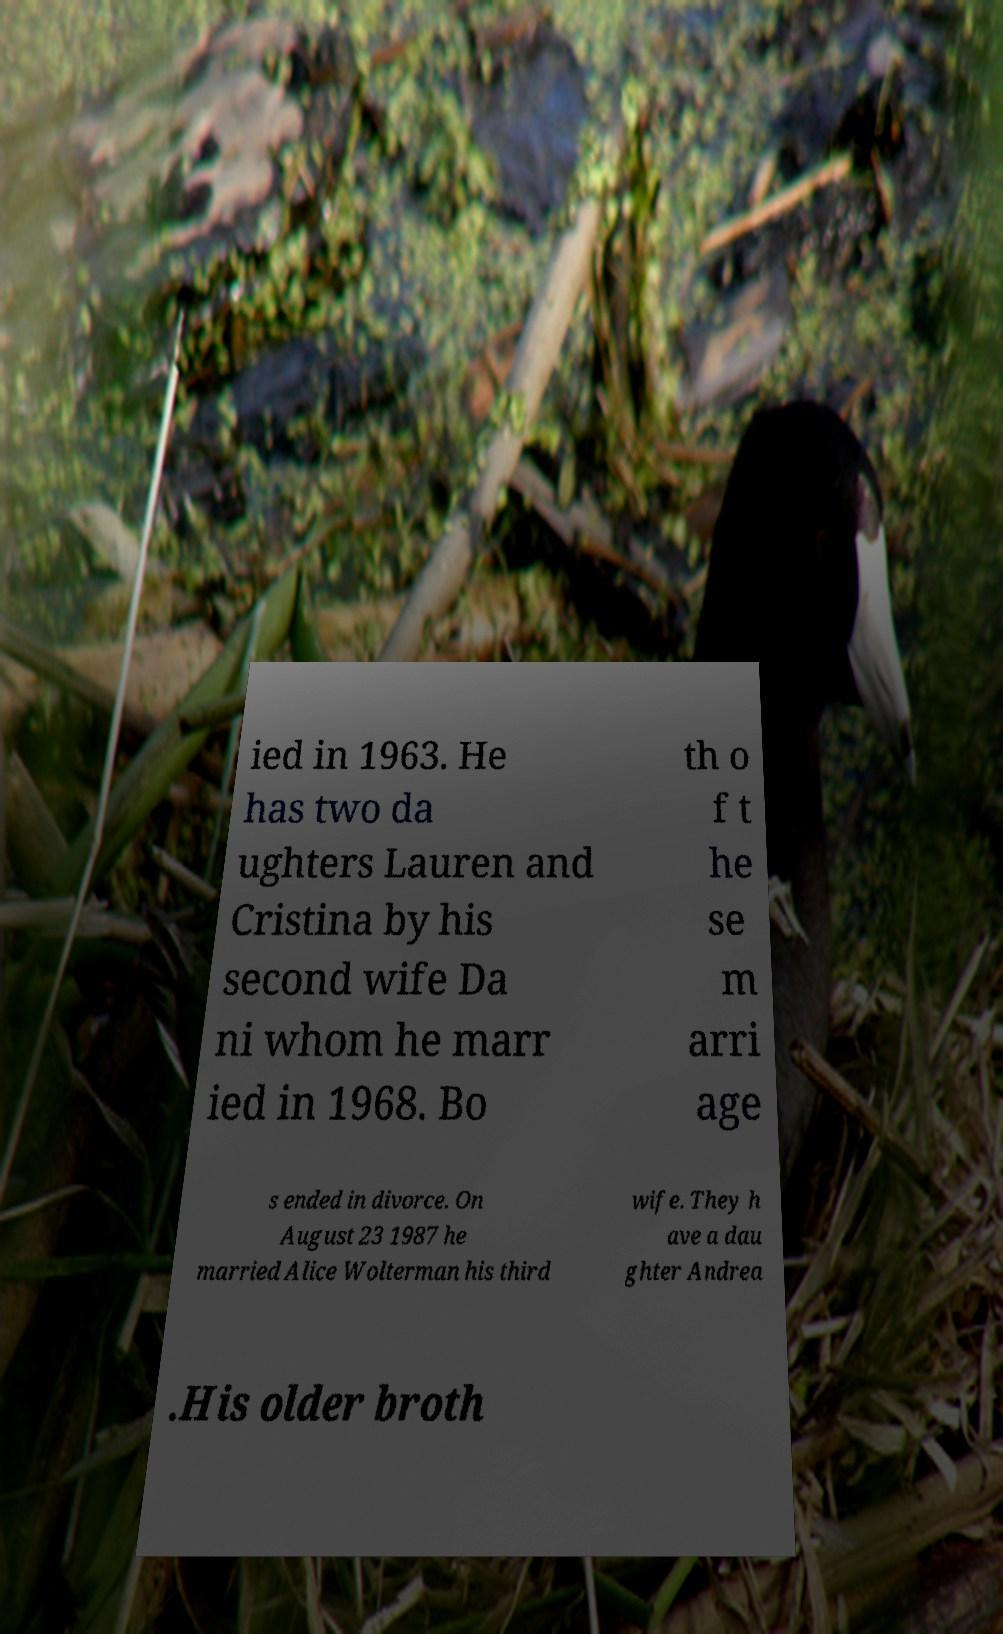There's text embedded in this image that I need extracted. Can you transcribe it verbatim? ied in 1963. He has two da ughters Lauren and Cristina by his second wife Da ni whom he marr ied in 1968. Bo th o f t he se m arri age s ended in divorce. On August 23 1987 he married Alice Wolterman his third wife. They h ave a dau ghter Andrea .His older broth 